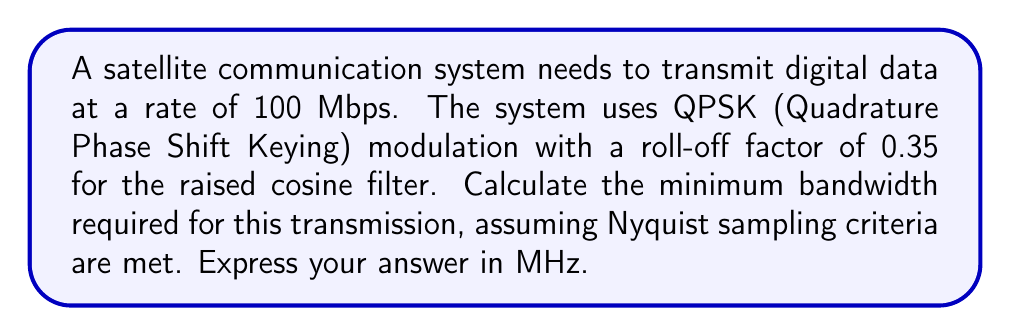Could you help me with this problem? To solve this problem, we need to follow these steps:

1) First, recall that QPSK modulation encodes 2 bits per symbol. So we need to calculate the symbol rate:

   Symbol rate = Data rate / Bits per symbol
   $$ R_s = \frac{100 \times 10^6}{2} = 50 \times 10^6 \text{ symbols/second} $$

2) Now, we can use the formula for bandwidth of a raised cosine filter:

   $$ B = R_s(1 + \alpha) $$

   Where:
   $B$ is the bandwidth
   $R_s$ is the symbol rate
   $\alpha$ is the roll-off factor

3) Substituting our values:

   $$ B = 50 \times 10^6 (1 + 0.35) $$
   $$ B = 50 \times 10^6 \times 1.35 $$
   $$ B = 67.5 \times 10^6 \text{ Hz} $$

4) Converting to MHz:

   $$ B = 67.5 \text{ MHz} $$

This is the minimum bandwidth required for the transmission, meeting the Nyquist criteria and accounting for the raised cosine filter's spectral shaping.
Answer: 67.5 MHz 